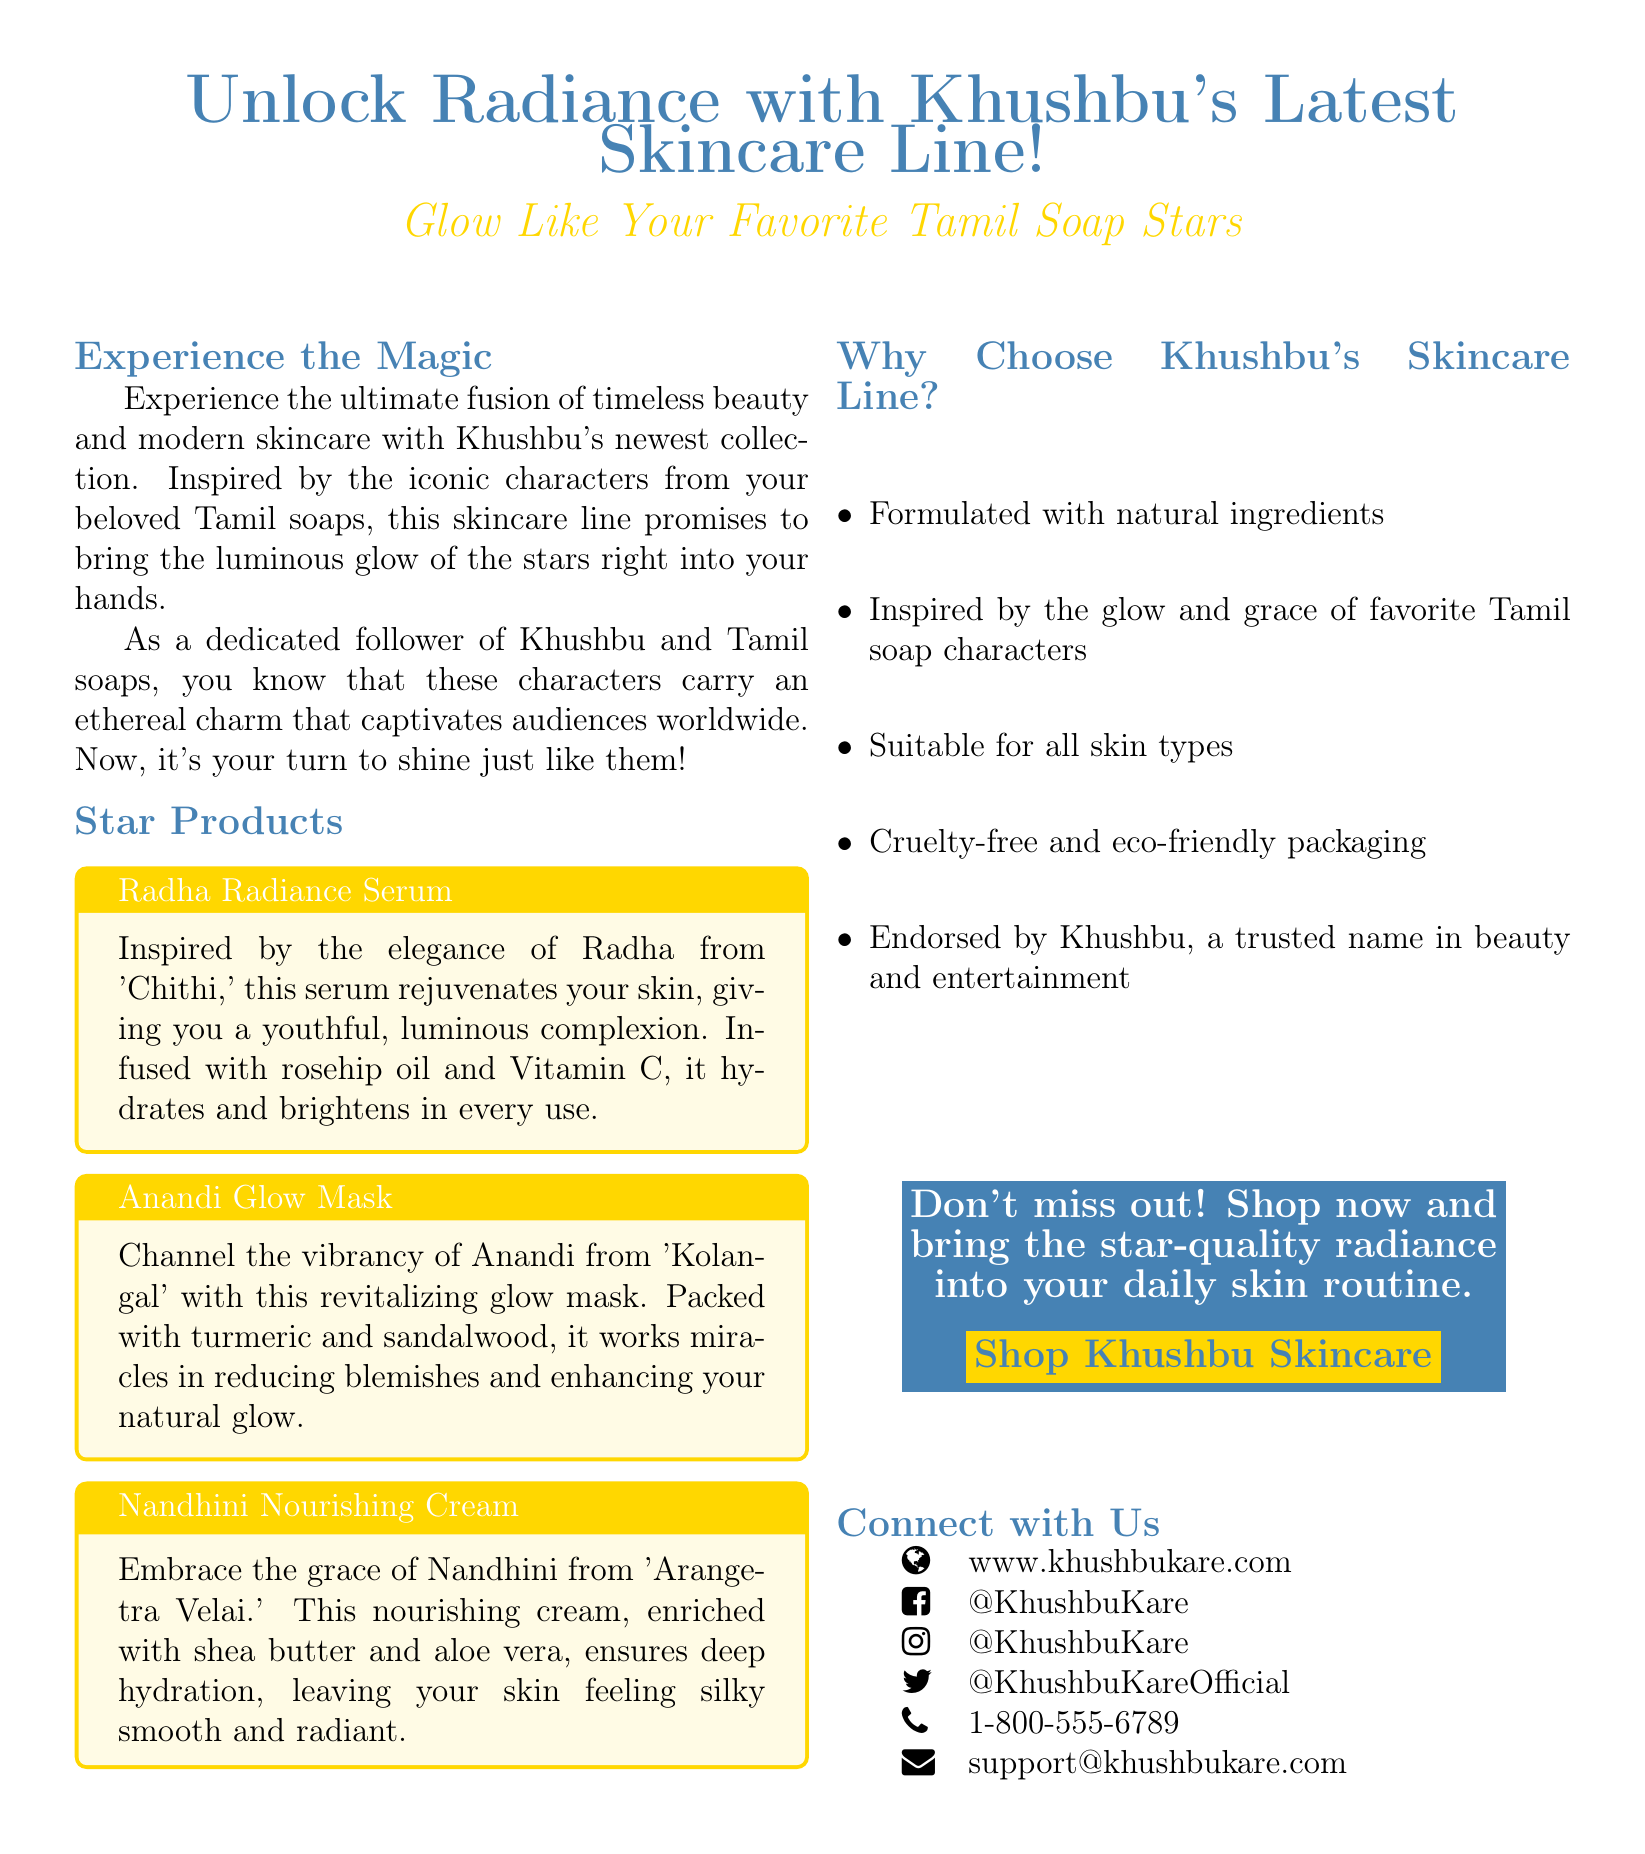What is the name of Khushbu's skincare line? The name of the skincare line is highlighted in the document as "Khushbu's Latest Skincare Line."
Answer: Khushbu's Latest Skincare Line What is the first product mentioned in the advertisement? The first product mentioned, along with its description, is "Radha Radiance Serum."
Answer: Radha Radiance Serum What ingredient is included in the Anandi Glow Mask? The Anandi Glow Mask is described as being "packed with turmeric and sandalwood."
Answer: Turmeric and sandalwood Who is the iconic character associated with the Nandhini Nourishing Cream? The cream is associated with "Nandhini from 'Arangetra Velai.'"
Answer: Nandhini What type of skin is the skincare line suitable for? The document states that the products are "suitable for all skin types."
Answer: All skin types What is the main feature of Khushbu's skincare line mentioned in the advertisement? The advertisement highlights that the skincare line is "formulated with natural ingredients."
Answer: Natural ingredients How can customers contact Khushbu's skincare line support? One of the contact methods listed is the email, "support@khushbukare.com."
Answer: support@khushbukare.com What is the color of the title text for the advertisement? The title text is in the color "soapblue."
Answer: soapblue What is the promotional message encouraging customers to take action? The message encourages customers by saying, "Don't miss out! Shop now and bring the star-quality radiance into your daily skin routine."
Answer: Don't miss out! Shop now 